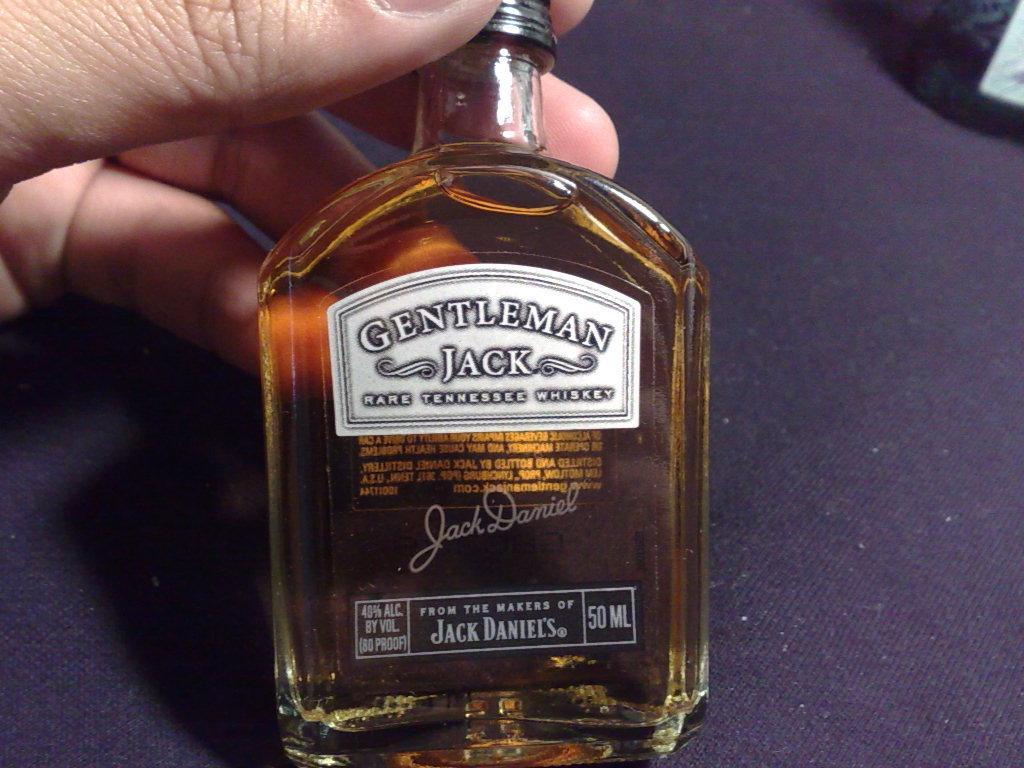Who or what is present in the image? There is a person in the image. What is the person holding in the image? The person is holding a Jack Daniels bottle. Where is the bottle located in the image? The bottle is on a table. What type of tin can be seen in the image? There is no tin present in the image. How many socks are visible in the image? There are no socks visible in the image. 